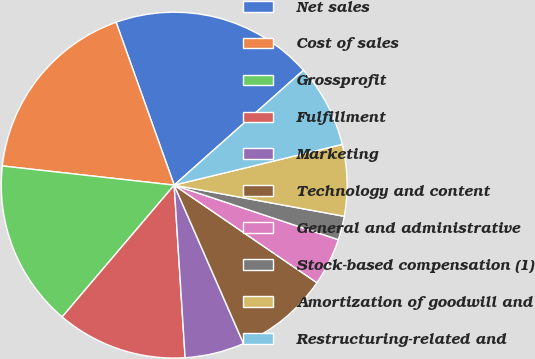Convert chart to OTSL. <chart><loc_0><loc_0><loc_500><loc_500><pie_chart><fcel>Net sales<fcel>Cost of sales<fcel>Grossprofit<fcel>Fulfillment<fcel>Marketing<fcel>Technology and content<fcel>General and administrative<fcel>Stock-based compensation (1)<fcel>Amortization of goodwill and<fcel>Restructuring-related and<nl><fcel>18.89%<fcel>17.78%<fcel>15.56%<fcel>12.22%<fcel>5.56%<fcel>8.89%<fcel>4.44%<fcel>2.22%<fcel>6.67%<fcel>7.78%<nl></chart> 